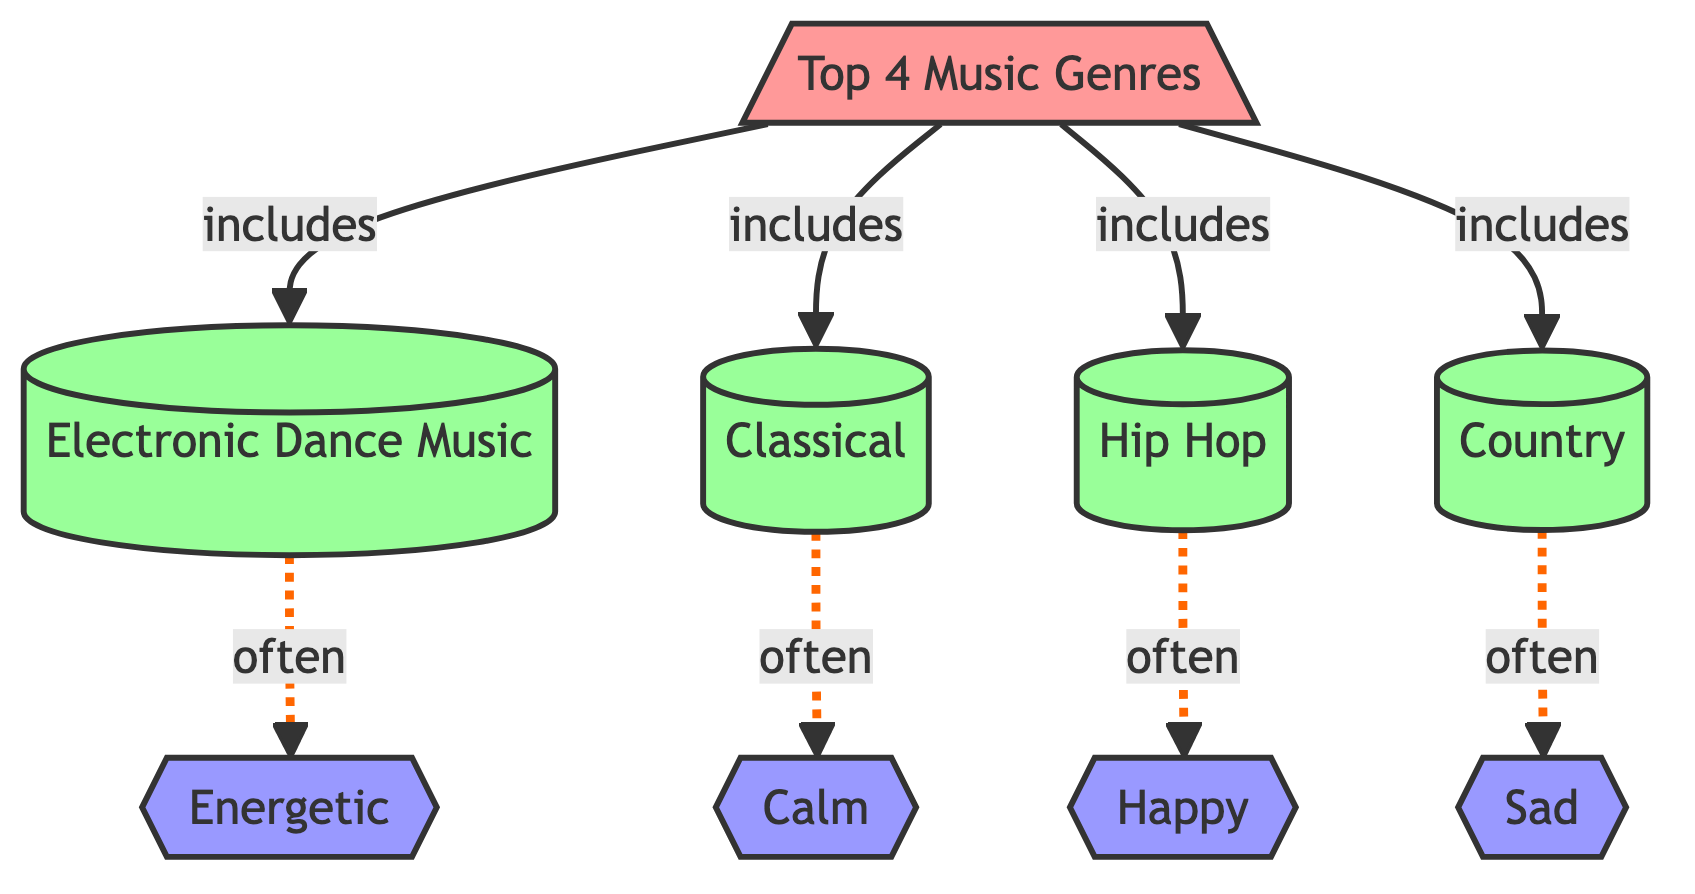What are the top 4 music genres listed in the diagram? The diagram specifies the "Top 4 Music Genres," including Electronic Dance Music, Classical, Hip Hop, and Country.
Answer: Electronic Dance Music, Classical, Hip Hop, Country Which mood is often associated with Electronic Dance Music? According to the diagram, Electronic Dance Music is often linked to the mood "Energetic."
Answer: Energetic What is the mood commonly related to Classical music? The diagram indicates that Classical music is often related to the mood "Calm."
Answer: Calm How many moods are listed in the diagram? There are four moods indicated in the diagram: Happy, Sad, Energetic, and Calm.
Answer: Four Which music genre is associated with the "Sad" mood? From the diagram, Country music is typically associated with the "Sad" mood.
Answer: Country If Classical music is playing, what mood do you expect to feel? Since the diagram states that Classical music is often linked to the mood "Calm," one would expect to feel Calm.
Answer: Calm Which mood is linked to Hip Hop according to the diagram? The diagram shows that Hip Hop is often associated with the mood "Happy."
Answer: Happy What type of relationship exists between each genre and its associated mood? Each music genre has a dotted relationship indicating they are "often" felt together with their respective mood in the diagram.
Answer: Often 